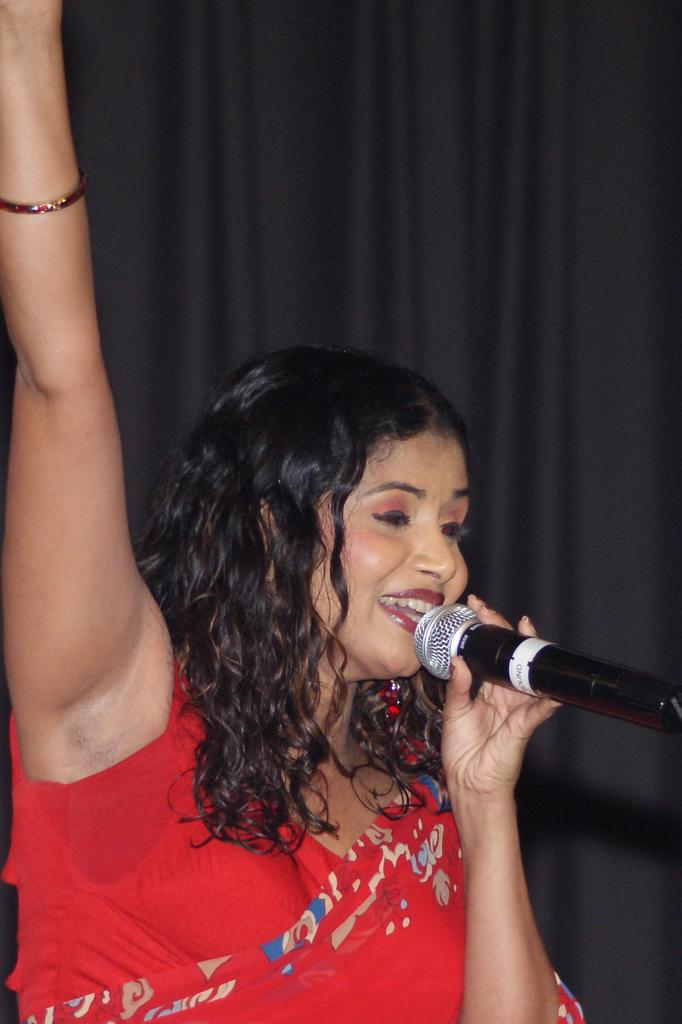Who or what is the main subject in the image? There is a person in the image. What is the person wearing? The person is wearing a red dress. What object is the person holding in her hand? The person is holding a microphone in her hand. How many turkeys can be seen in the image? There are no turkeys present in the image. Is there a stranger in the image? The image only shows a person, and there is no indication that this person is a stranger. Can you see any ducks in the image? There are no ducks present in the image. 